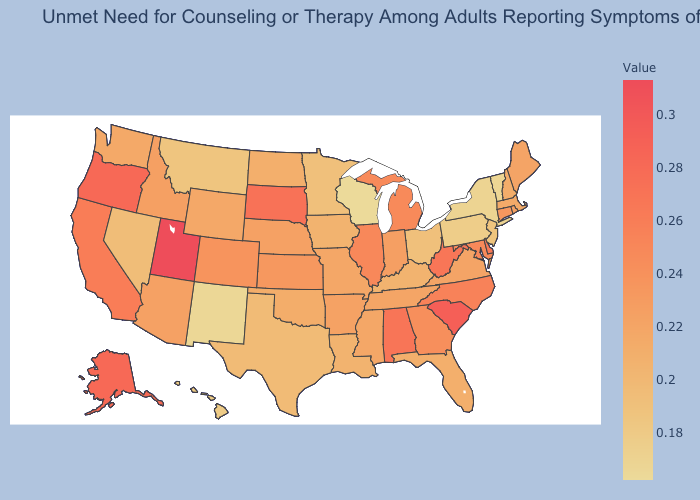Among the states that border Virginia , does Maryland have the lowest value?
Write a very short answer. No. Which states have the lowest value in the MidWest?
Write a very short answer. Wisconsin. Which states have the lowest value in the USA?
Be succinct. Wisconsin. Among the states that border Pennsylvania , does West Virginia have the highest value?
Keep it brief. Yes. Among the states that border Iowa , does Wisconsin have the highest value?
Keep it brief. No. 